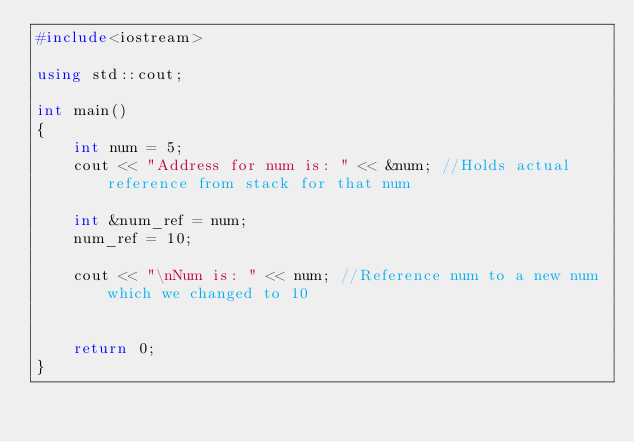<code> <loc_0><loc_0><loc_500><loc_500><_C++_>#include<iostream>

using std::cout;

int main() 
{
	int num = 5;
	cout << "Address for num is: " << &num; //Holds actual reference from stack for that num

	int &num_ref = num;
	num_ref = 10;

	cout << "\nNum is: " << num; //Reference num to a new num which we changed to 10


	return 0;
}</code> 